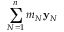<formula> <loc_0><loc_0><loc_500><loc_500>\sum _ { N = 1 } ^ { n } m _ { N } { y } _ { N }</formula> 